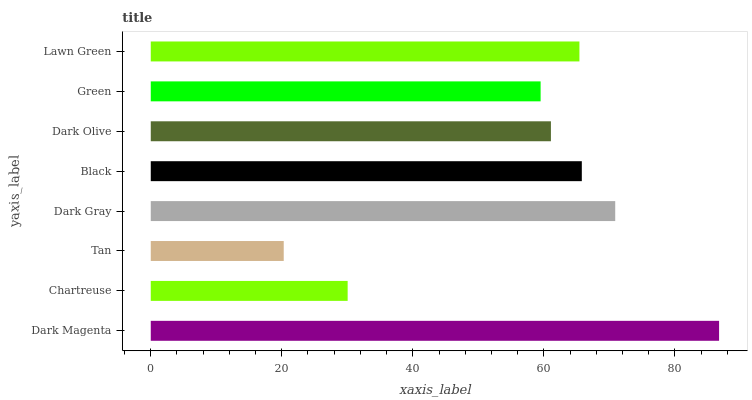Is Tan the minimum?
Answer yes or no. Yes. Is Dark Magenta the maximum?
Answer yes or no. Yes. Is Chartreuse the minimum?
Answer yes or no. No. Is Chartreuse the maximum?
Answer yes or no. No. Is Dark Magenta greater than Chartreuse?
Answer yes or no. Yes. Is Chartreuse less than Dark Magenta?
Answer yes or no. Yes. Is Chartreuse greater than Dark Magenta?
Answer yes or no. No. Is Dark Magenta less than Chartreuse?
Answer yes or no. No. Is Lawn Green the high median?
Answer yes or no. Yes. Is Dark Olive the low median?
Answer yes or no. Yes. Is Dark Olive the high median?
Answer yes or no. No. Is Lawn Green the low median?
Answer yes or no. No. 